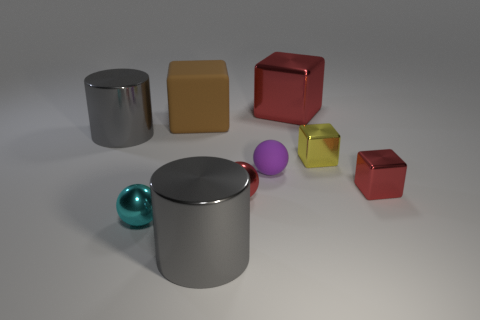What is the material of the tiny yellow object?
Keep it short and to the point. Metal. Is the number of large red metal cubes greater than the number of red objects?
Your answer should be very brief. No. Is the shape of the cyan metallic thing the same as the yellow metallic object?
Your response must be concise. No. There is a block that is in front of the small yellow shiny thing; does it have the same color as the large metallic thing that is to the right of the matte sphere?
Your answer should be compact. Yes. Are there fewer tiny purple balls that are right of the big red metallic object than cyan things that are on the left side of the large brown matte thing?
Offer a terse response. Yes. What is the shape of the large gray object that is in front of the small purple object?
Give a very brief answer. Cylinder. What material is the ball that is the same color as the large shiny cube?
Offer a very short reply. Metal. What number of other objects are the same material as the brown object?
Your answer should be very brief. 1. There is a tiny purple matte thing; does it have the same shape as the big shiny thing that is to the left of the large matte block?
Provide a succinct answer. No. What is the shape of the small yellow thing that is made of the same material as the small red block?
Give a very brief answer. Cube. 